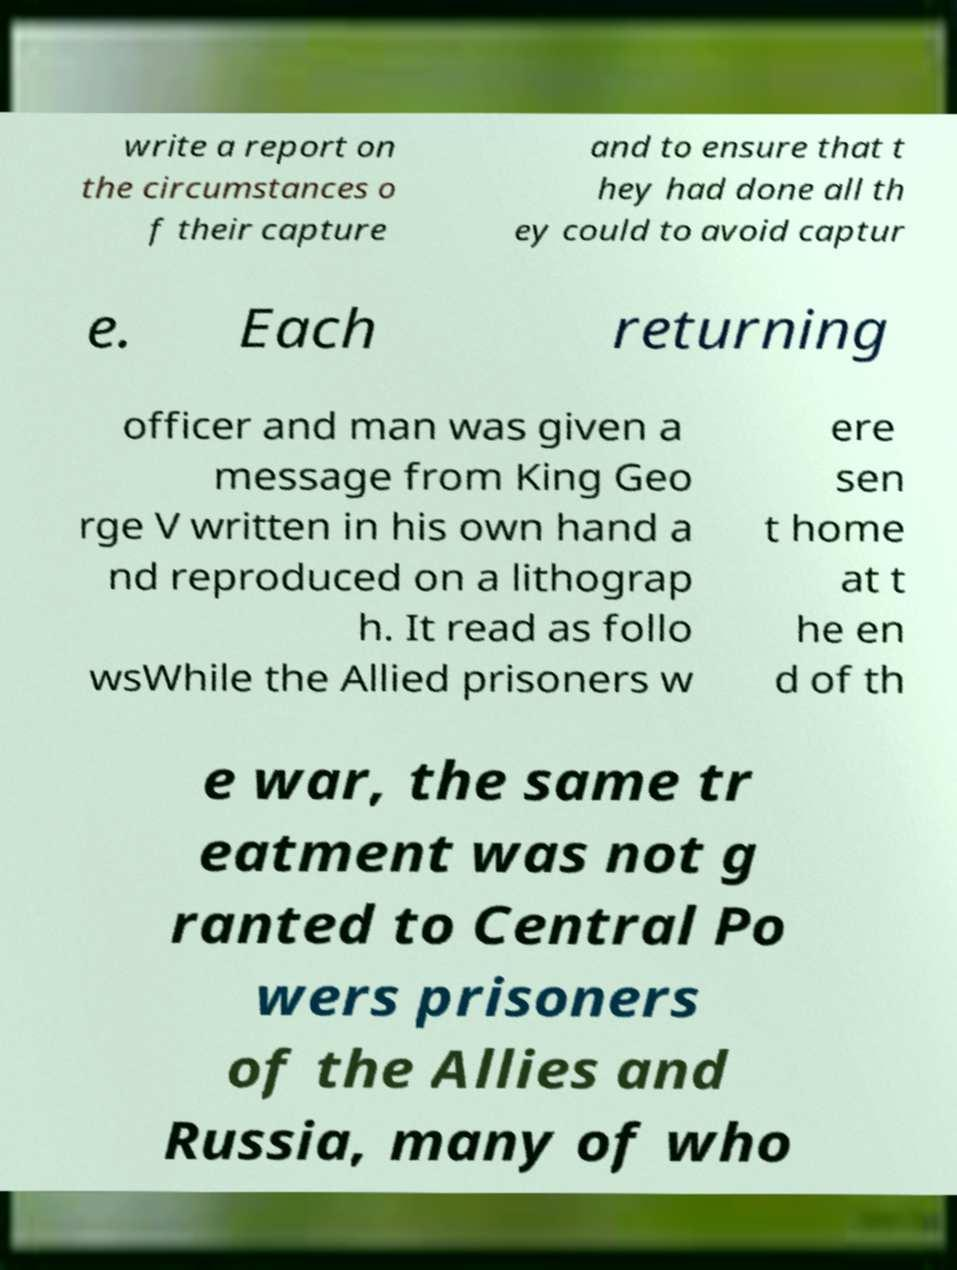I need the written content from this picture converted into text. Can you do that? write a report on the circumstances o f their capture and to ensure that t hey had done all th ey could to avoid captur e. Each returning officer and man was given a message from King Geo rge V written in his own hand a nd reproduced on a lithograp h. It read as follo wsWhile the Allied prisoners w ere sen t home at t he en d of th e war, the same tr eatment was not g ranted to Central Po wers prisoners of the Allies and Russia, many of who 